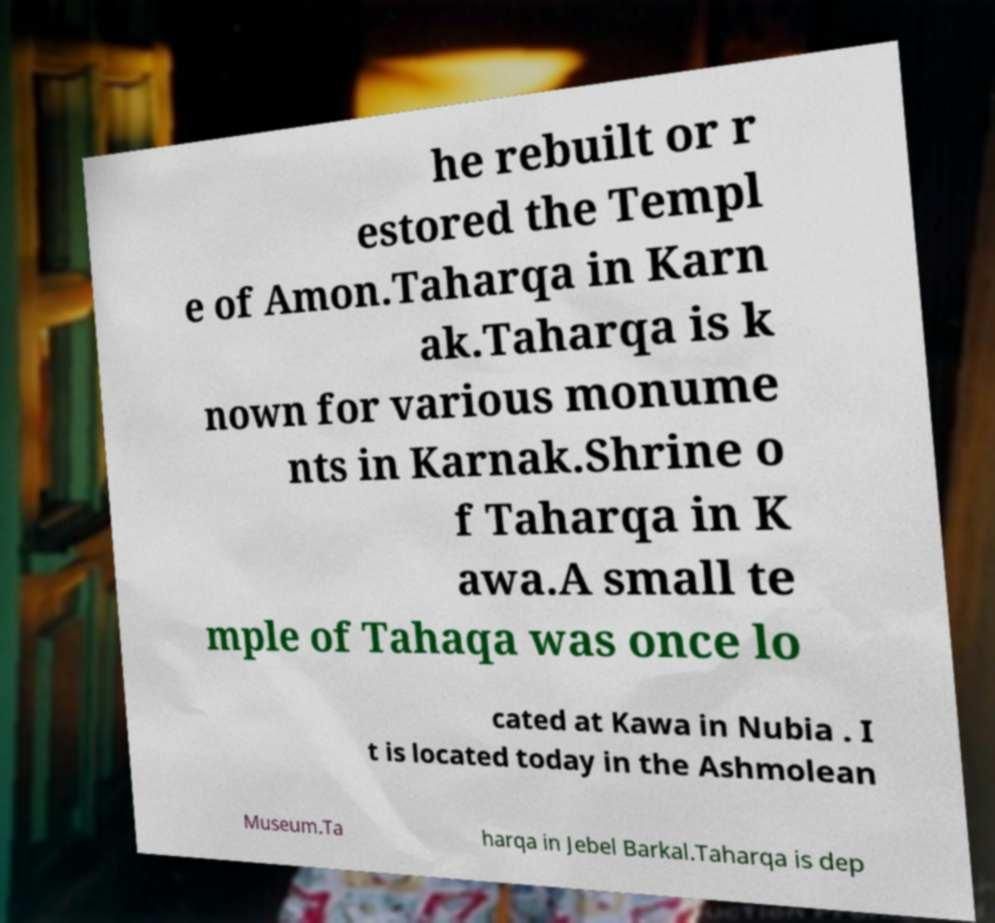There's text embedded in this image that I need extracted. Can you transcribe it verbatim? he rebuilt or r estored the Templ e of Amon.Taharqa in Karn ak.Taharqa is k nown for various monume nts in Karnak.Shrine o f Taharqa in K awa.A small te mple of Tahaqa was once lo cated at Kawa in Nubia . I t is located today in the Ashmolean Museum.Ta harqa in Jebel Barkal.Taharqa is dep 